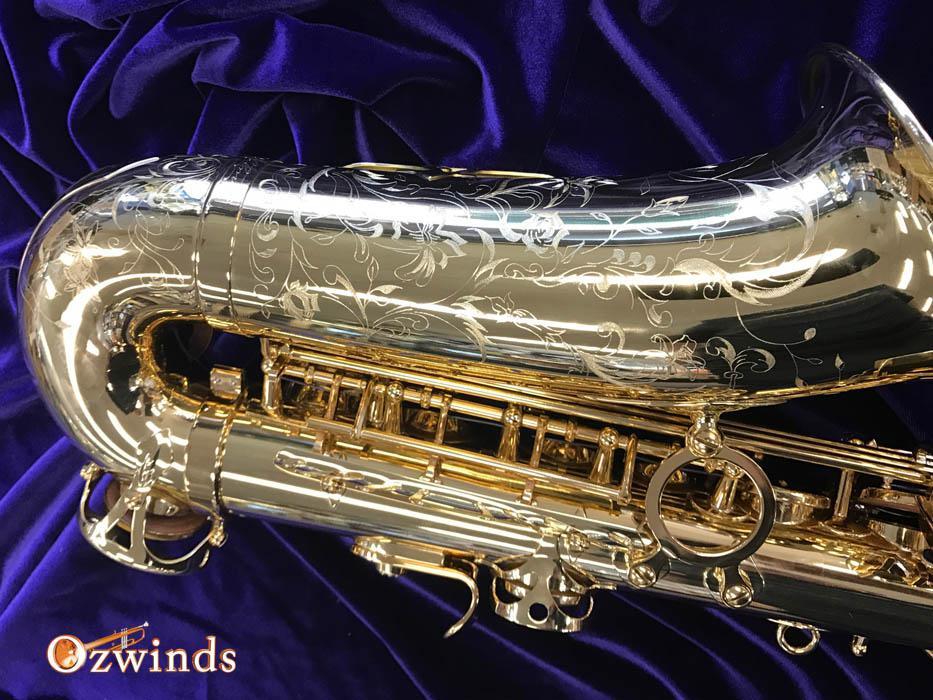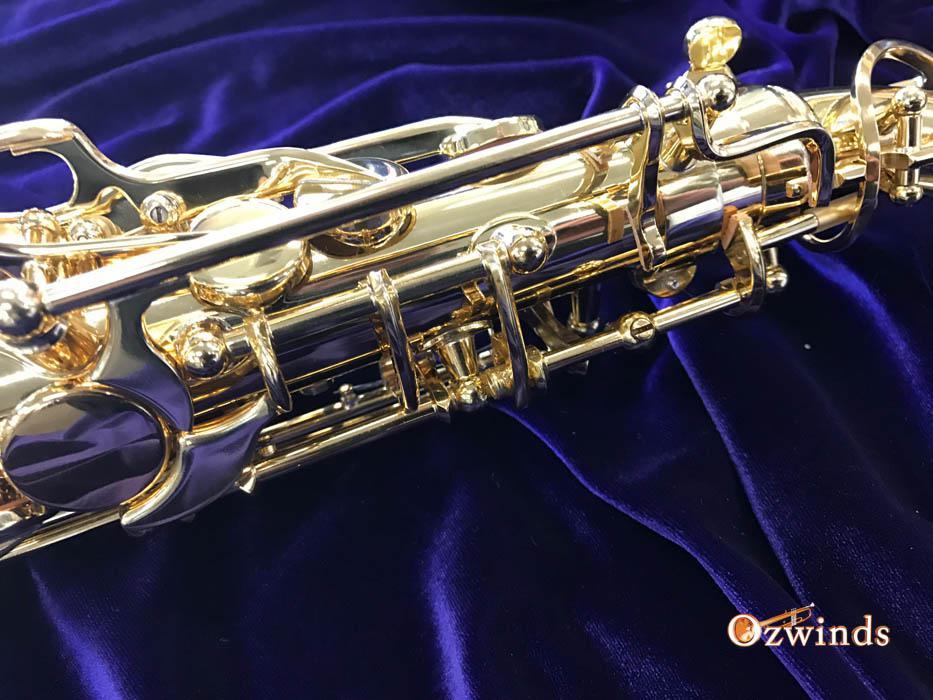The first image is the image on the left, the second image is the image on the right. Considering the images on both sides, is "Each image shows a saxophone displayed on folds of blue velvet, and in one image, the bell end of the saxophone is visible and facing upward." valid? Answer yes or no. Yes. 